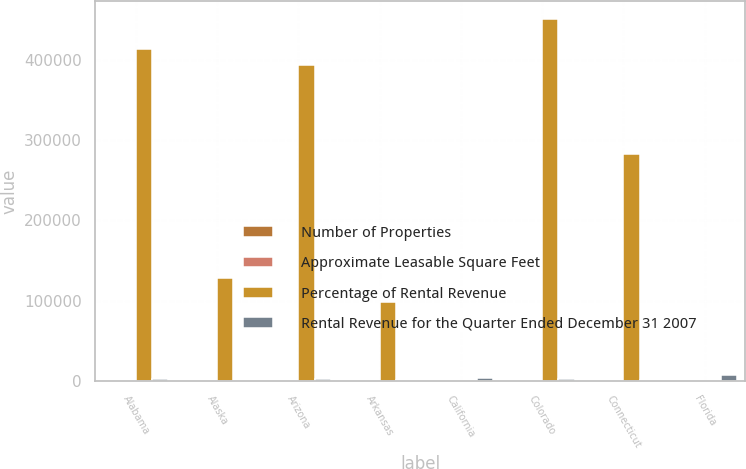Convert chart. <chart><loc_0><loc_0><loc_500><loc_500><stacked_bar_chart><ecel><fcel>Alabama<fcel>Alaska<fcel>Arizona<fcel>Arkansas<fcel>California<fcel>Colorado<fcel>Connecticut<fcel>Florida<nl><fcel>Number of Properties<fcel>61<fcel>2<fcel>79<fcel>18<fcel>63<fcel>54<fcel>26<fcel>168<nl><fcel>Approximate Leasable Square Feet<fcel>98<fcel>100<fcel>99<fcel>100<fcel>98<fcel>98<fcel>100<fcel>98<nl><fcel>Percentage of Rental Revenue<fcel>413700<fcel>128500<fcel>394100<fcel>98500<fcel>134<fcel>451000<fcel>282300<fcel>134<nl><fcel>Rental Revenue for the Quarter Ended December 31 2007<fcel>1885<fcel>277<fcel>2426<fcel>436<fcel>4072<fcel>1943<fcel>1324<fcel>6706<nl></chart> 